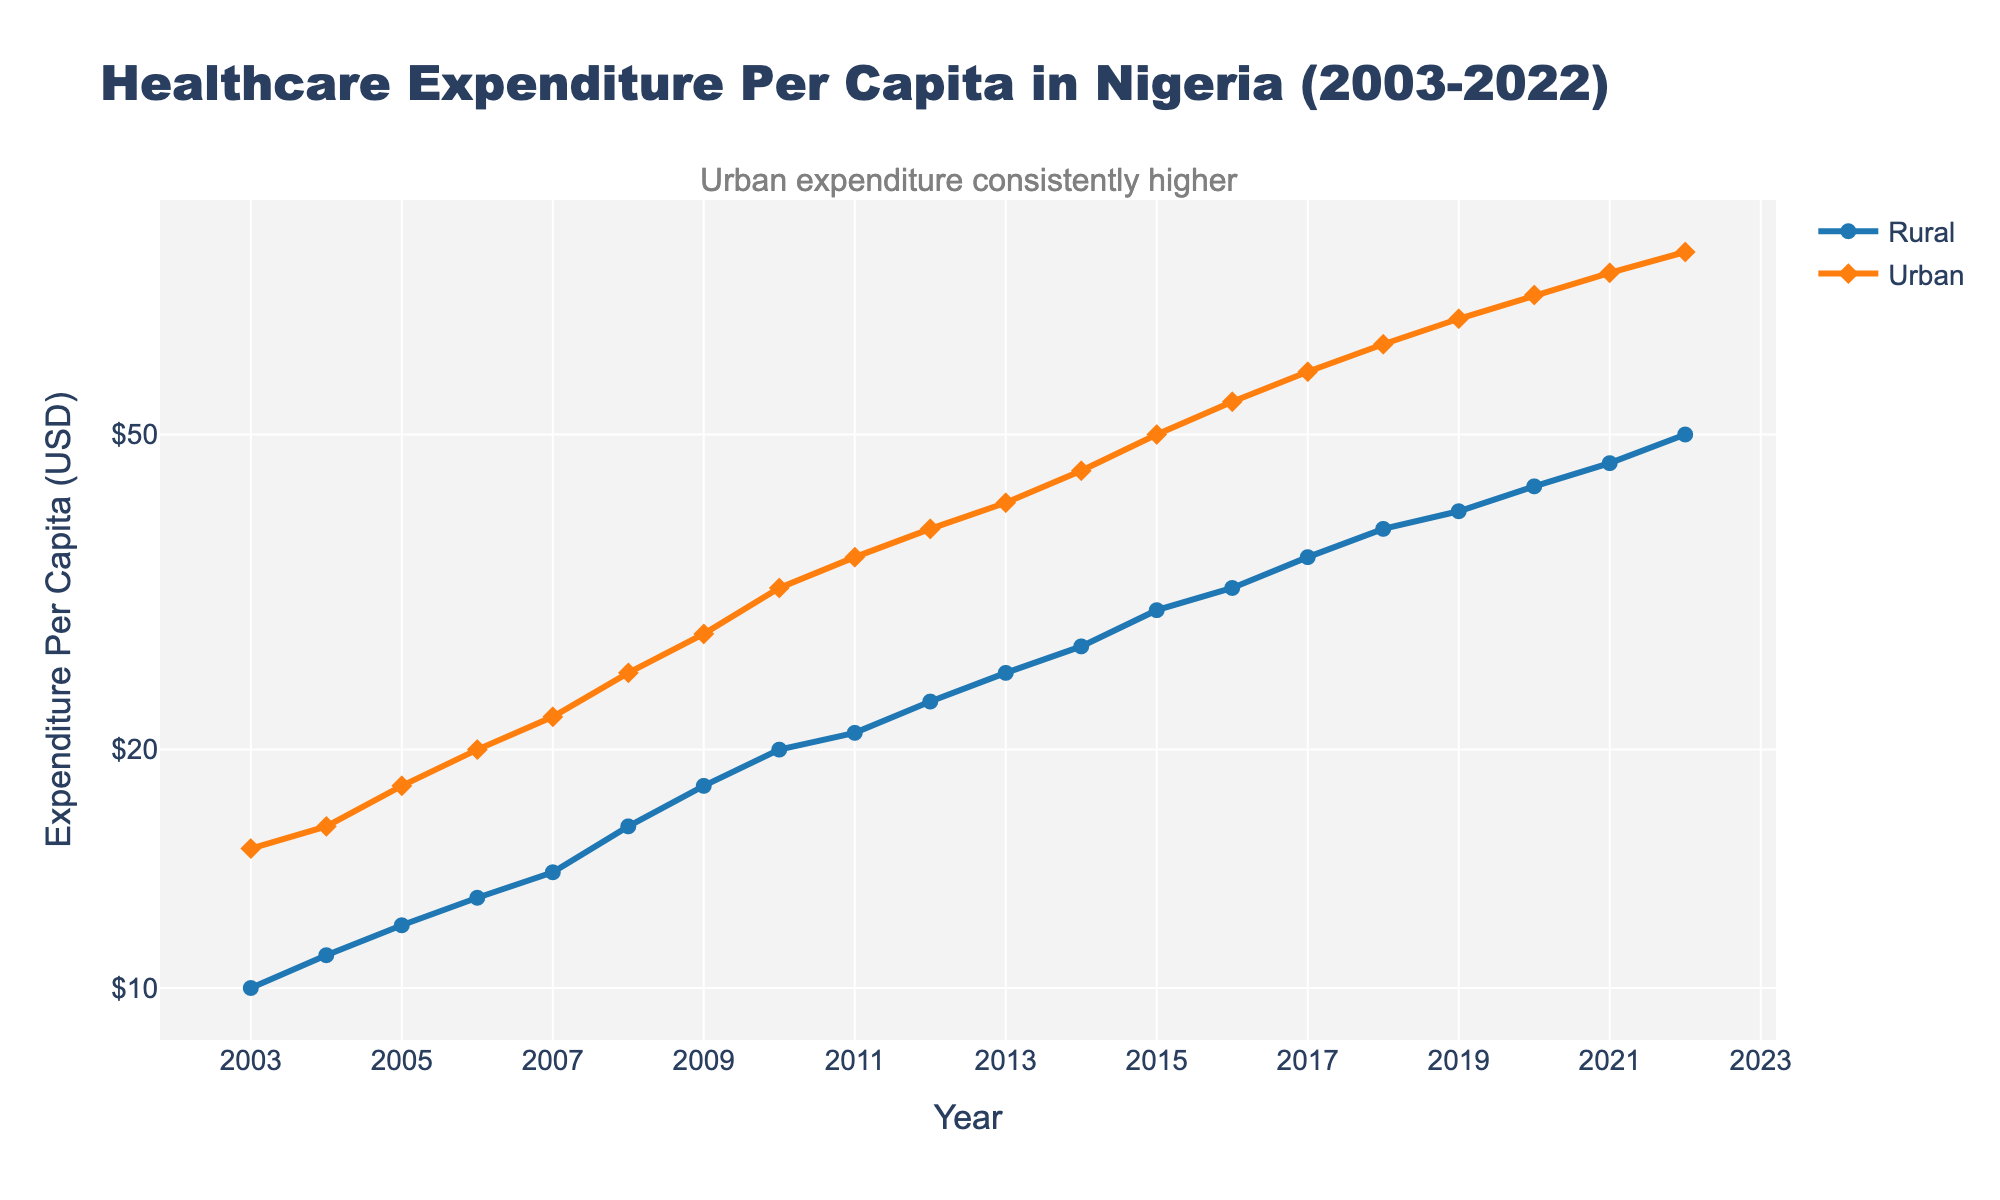What is the title of the figure? The title is displayed at the top of the chart. It reads 'Healthcare Expenditure Per Capita in Nigeria (2003-2022)'.
Answer: Healthcare Expenditure Per Capita in Nigeria (2003-2022) Which population segment shows higher healthcare expenditure per capita in each year? By observing the chart, you can see that the line representing the Urban population (orange) is always above the line representing the Rural population (blue), indicating consistently higher expenditures.
Answer: Urban How much higher was the healthcare expenditure per capita in urban areas compared to rural areas in 2022? From the figure, in 2022, the expenditure for rural areas was $50 and for urban areas was $85. The difference is $85 - $50.
Answer: $35 Do healthcare expenditures per capita in both rural and urban areas display upward trends over the period 2003-2022? Both lines are consistently increasing over time, indicating that healthcare expenditures per capita for both rural and urban areas are on an upward trend.
Answer: Yes At what year did the rural population first reach a per capita healthcare expenditure of $20? Following the blue line upwards, it first crosses the $20 mark in the year 2010.
Answer: 2010 On a log scale, does the gap between urban and rural healthcare expenditures per capita widen, narrow, or remain consistent over time? Visually, the gap between the lines widens on the log scale, indicating that the difference is growing exponentially over time rather than linearly.
Answer: Widens How many distinct data points are shown for the rural and urban population segments? Each year from 2003 to 2022 has data points for both rural and urban segments, making it 20 years * 2 data points each year.
Answer: 40 